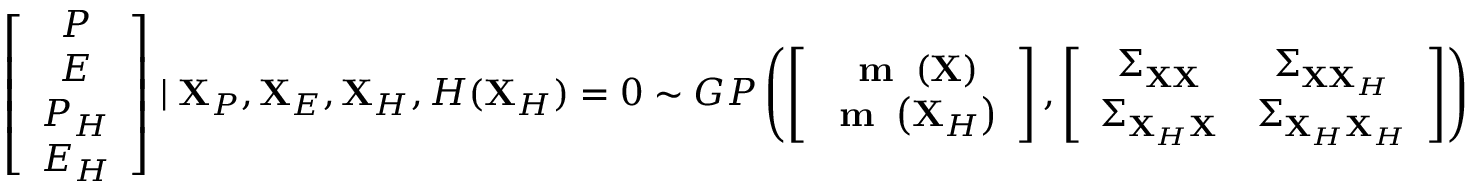<formula> <loc_0><loc_0><loc_500><loc_500>\left [ \begin{array} { c } { P } \\ { E } \\ { P _ { H } } \\ { E _ { H } } \end{array} \right ] | X _ { P } , X _ { E } , X _ { H } , H ( X _ { H } ) = 0 \sim G P \left ( \left [ \begin{array} { c } { m \left ( X \right ) } \\ { m \left ( X _ { H } \right ) } \end{array} \right ] , \left [ \begin{array} { c c } { \Sigma _ { X X } } & { \Sigma _ { X X _ { H } } } \\ { \Sigma _ { X _ { H } X } } & { \Sigma _ { X _ { H } X _ { H } } } \end{array} \right ] \right )</formula> 